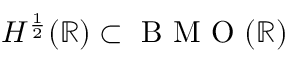Convert formula to latex. <formula><loc_0><loc_0><loc_500><loc_500>H ^ { \frac { 1 } { 2 } } ( \mathbb { R } ) \subset B M O ( \mathbb { R } )</formula> 